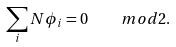<formula> <loc_0><loc_0><loc_500><loc_500>\sum _ { i } N \phi _ { i } = 0 \quad m o d 2 .</formula> 